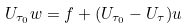Convert formula to latex. <formula><loc_0><loc_0><loc_500><loc_500>U _ { \tau _ { 0 } } w = f + ( U _ { \tau _ { 0 } } - U _ { \tau } ) u</formula> 